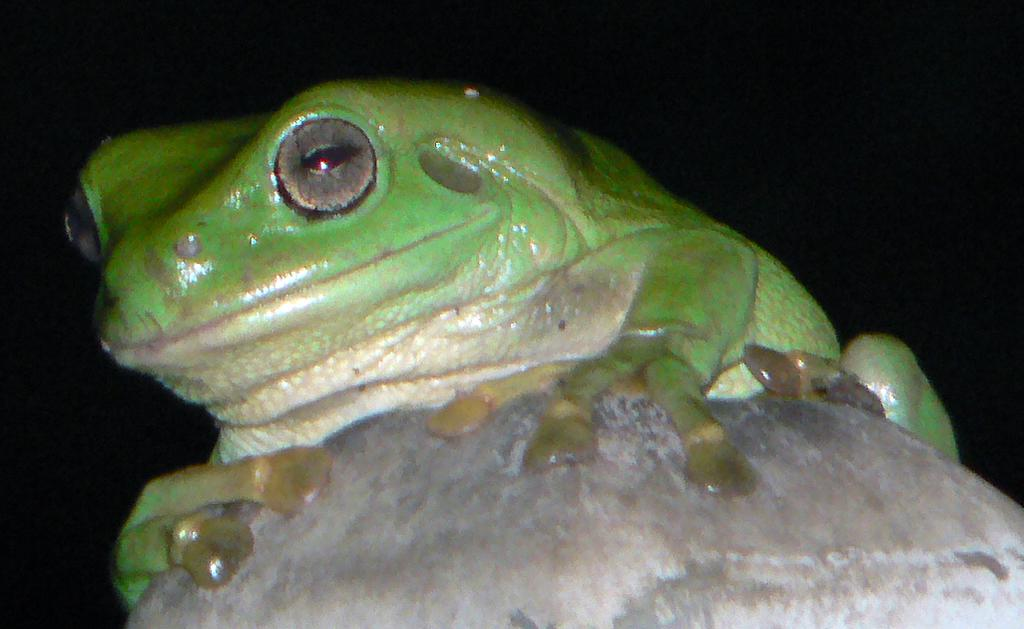What type of animal is in the image? There is a frog in the image. What color is the frog? The frog is green in color. Where is the frog located in the image? The frog is on a stone. What advice does the frog's dad give to the frog in the image? There is no mention of a dad or any advice in the image; it simply shows a green frog on a stone. 